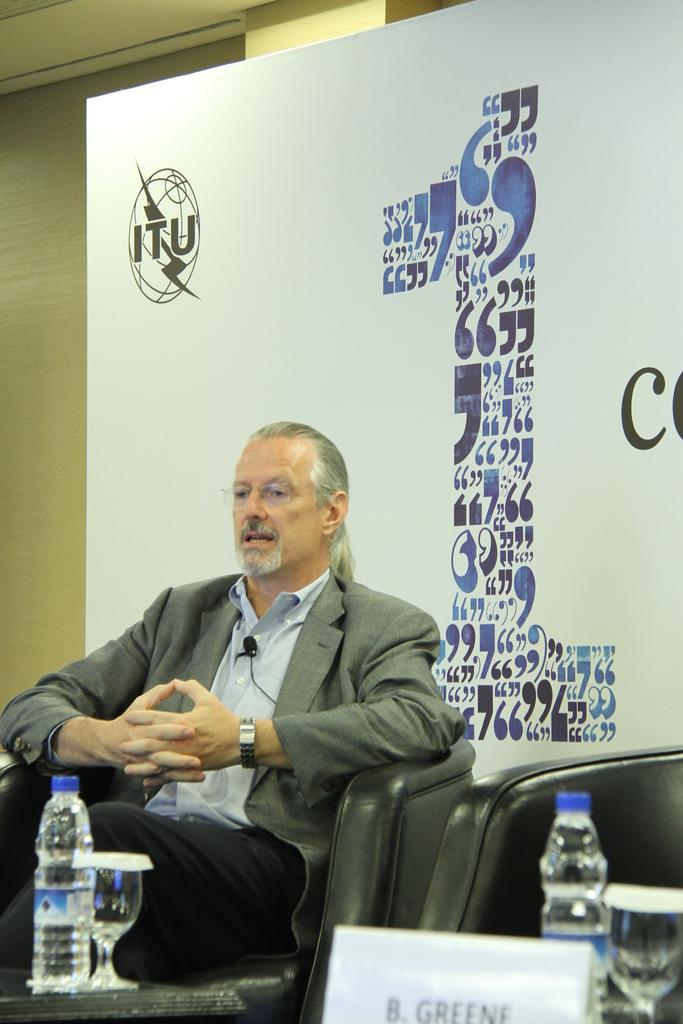What is the person in the image doing? The person is sitting on a chair. What objects are in front of the person? There is a glass and a bottle in front of the person. What can be seen behind the person? There is a banner behind the person. What is written on the banner? The banner has "IT" written on it. What religious beliefs does the person in the image follow? There is no information about the person's religious beliefs in the image. How does the person in the image express their anger? There is no indication of the person's emotions or expressions in the image. 